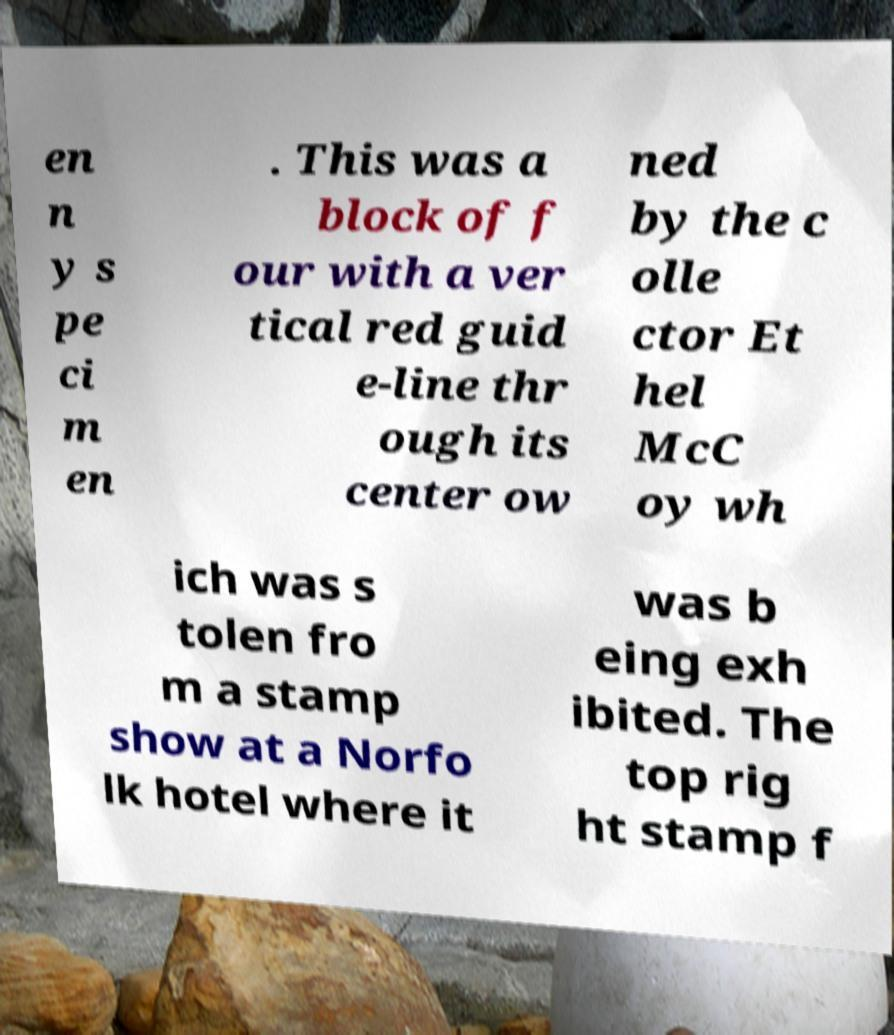Please read and relay the text visible in this image. What does it say? en n y s pe ci m en . This was a block of f our with a ver tical red guid e-line thr ough its center ow ned by the c olle ctor Et hel McC oy wh ich was s tolen fro m a stamp show at a Norfo lk hotel where it was b eing exh ibited. The top rig ht stamp f 